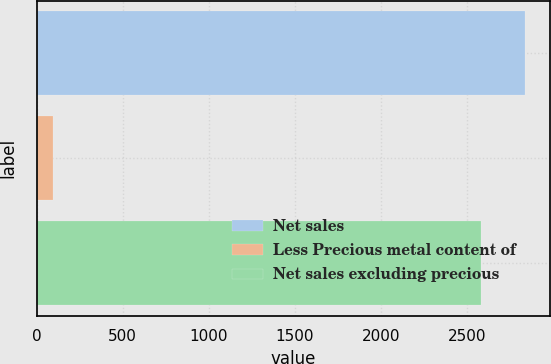Convert chart. <chart><loc_0><loc_0><loc_500><loc_500><bar_chart><fcel>Net sales<fcel>Less Precious metal content of<fcel>Net sales excluding precious<nl><fcel>2839.65<fcel>92.8<fcel>2581.5<nl></chart> 